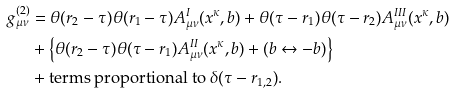Convert formula to latex. <formula><loc_0><loc_0><loc_500><loc_500>g _ { \mu \nu } ^ { ( 2 ) } & = \theta ( r _ { 2 } - \tau ) \theta ( r _ { 1 } - \tau ) A _ { \mu \nu } ^ { I } ( x ^ { \kappa } , b ) + \theta ( \tau - r _ { 1 } ) \theta ( \tau - r _ { 2 } ) A _ { \mu \nu } ^ { I I I } ( x ^ { \kappa } , b ) \\ & + \left \{ \theta ( r _ { 2 } - \tau ) \theta ( \tau - r _ { 1 } ) A _ { \mu \nu } ^ { I I } ( x ^ { \kappa } , b ) + \left ( b \leftrightarrow - b \right ) \right \} \\ & + \text {terms proportional to $\delta(\tau-r_{1,2})$} .</formula> 